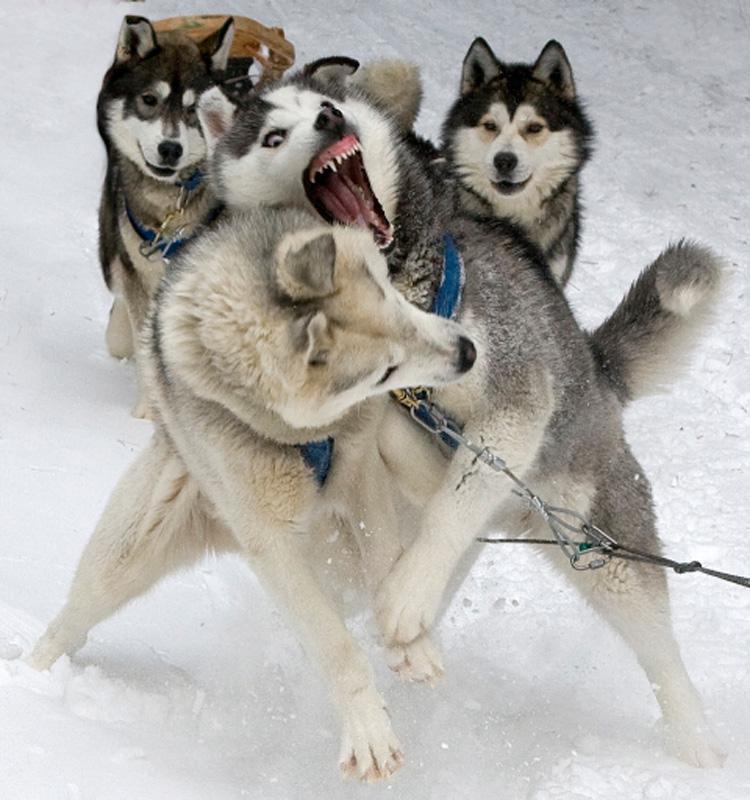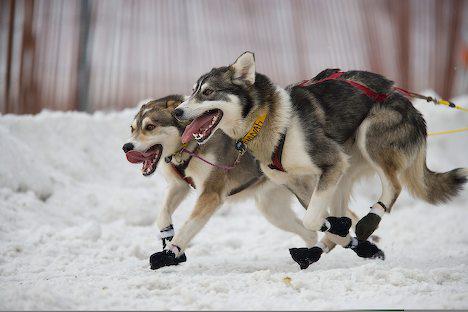The first image is the image on the left, the second image is the image on the right. Evaluate the accuracy of this statement regarding the images: "There are two walking husky harness together with the one on the right sticking out their tongue.". Is it true? Answer yes or no. No. The first image is the image on the left, the second image is the image on the right. For the images displayed, is the sentence "One image shows a sled dog team headed forward, and the other image shows two side-by-side dogs, the one on the right with its tongue hanging out." factually correct? Answer yes or no. No. 